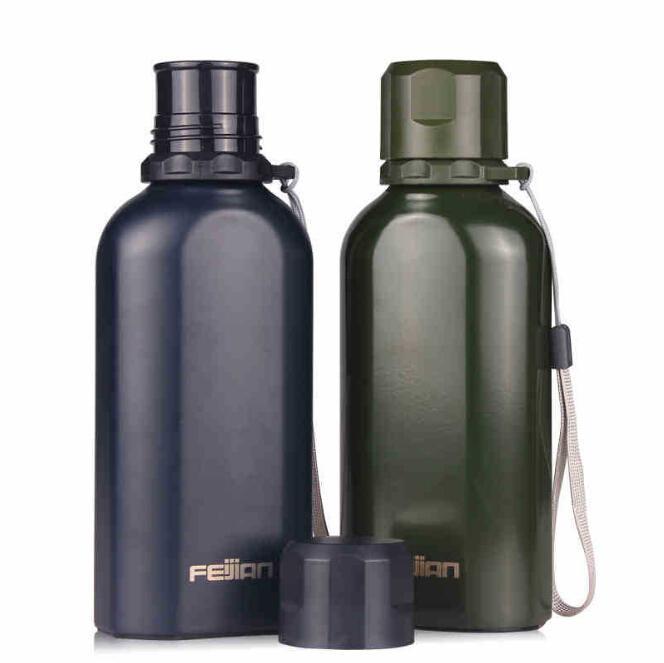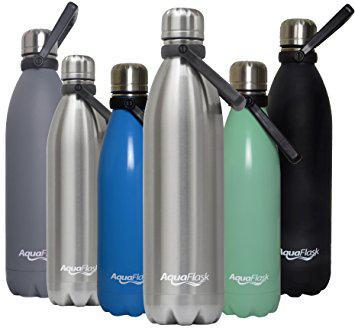The first image is the image on the left, the second image is the image on the right. Given the left and right images, does the statement "The right and left images contain the same number of water bottles." hold true? Answer yes or no. No. 